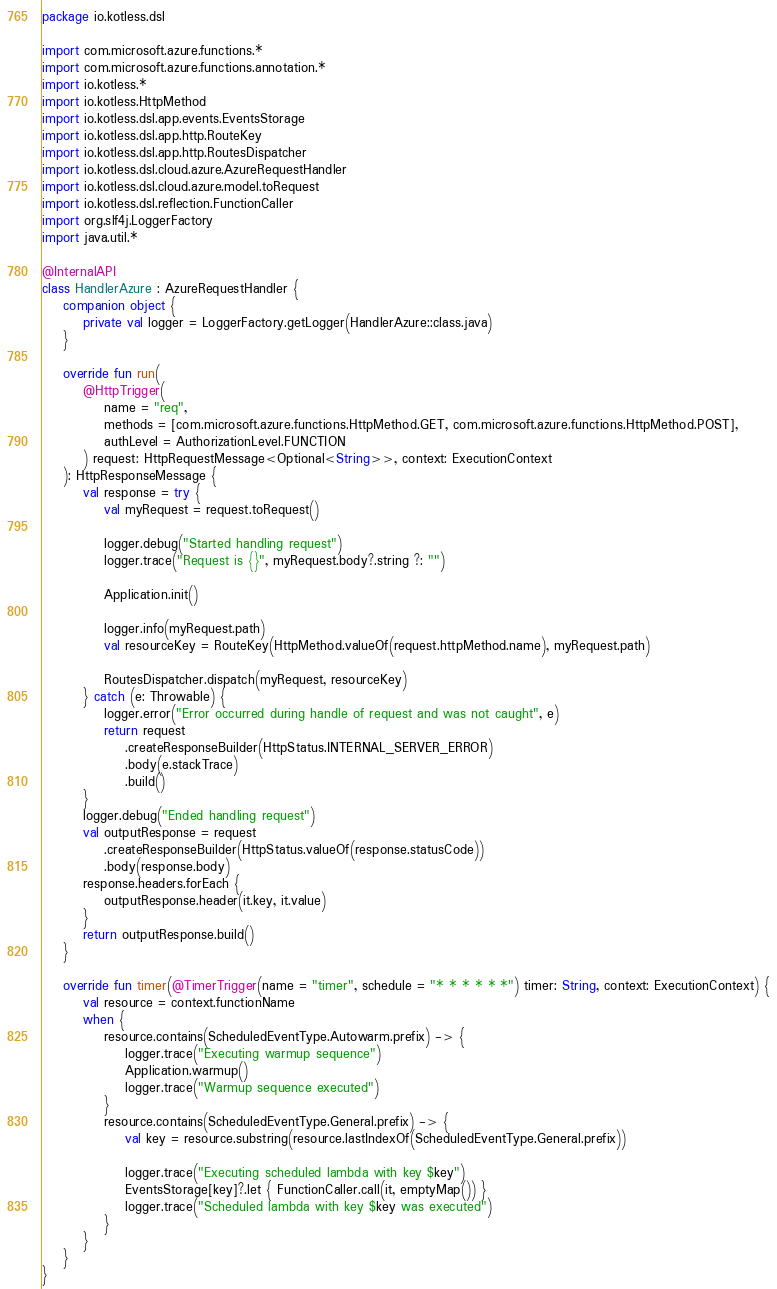<code> <loc_0><loc_0><loc_500><loc_500><_Kotlin_>package io.kotless.dsl

import com.microsoft.azure.functions.*
import com.microsoft.azure.functions.annotation.*
import io.kotless.*
import io.kotless.HttpMethod
import io.kotless.dsl.app.events.EventsStorage
import io.kotless.dsl.app.http.RouteKey
import io.kotless.dsl.app.http.RoutesDispatcher
import io.kotless.dsl.cloud.azure.AzureRequestHandler
import io.kotless.dsl.cloud.azure.model.toRequest
import io.kotless.dsl.reflection.FunctionCaller
import org.slf4j.LoggerFactory
import java.util.*

@InternalAPI
class HandlerAzure : AzureRequestHandler {
    companion object {
        private val logger = LoggerFactory.getLogger(HandlerAzure::class.java)
    }

    override fun run(
        @HttpTrigger(
            name = "req",
            methods = [com.microsoft.azure.functions.HttpMethod.GET, com.microsoft.azure.functions.HttpMethod.POST],
            authLevel = AuthorizationLevel.FUNCTION
        ) request: HttpRequestMessage<Optional<String>>, context: ExecutionContext
    ): HttpResponseMessage {
        val response = try {
            val myRequest = request.toRequest()

            logger.debug("Started handling request")
            logger.trace("Request is {}", myRequest.body?.string ?: "")

            Application.init()

            logger.info(myRequest.path)
            val resourceKey = RouteKey(HttpMethod.valueOf(request.httpMethod.name), myRequest.path)

            RoutesDispatcher.dispatch(myRequest, resourceKey)
        } catch (e: Throwable) {
            logger.error("Error occurred during handle of request and was not caught", e)
            return request
                .createResponseBuilder(HttpStatus.INTERNAL_SERVER_ERROR)
                .body(e.stackTrace)
                .build()
        }
        logger.debug("Ended handling request")
        val outputResponse = request
            .createResponseBuilder(HttpStatus.valueOf(response.statusCode))
            .body(response.body)
        response.headers.forEach {
            outputResponse.header(it.key, it.value)
        }
        return outputResponse.build()
    }

    override fun timer(@TimerTrigger(name = "timer", schedule = "* * * * * *") timer: String, context: ExecutionContext) {
        val resource = context.functionName
        when {
            resource.contains(ScheduledEventType.Autowarm.prefix) -> {
                logger.trace("Executing warmup sequence")
                Application.warmup()
                logger.trace("Warmup sequence executed")
            }
            resource.contains(ScheduledEventType.General.prefix) -> {
                val key = resource.substring(resource.lastIndexOf(ScheduledEventType.General.prefix))

                logger.trace("Executing scheduled lambda with key $key")
                EventsStorage[key]?.let { FunctionCaller.call(it, emptyMap()) }
                logger.trace("Scheduled lambda with key $key was executed")
            }
        }
    }
}
</code> 